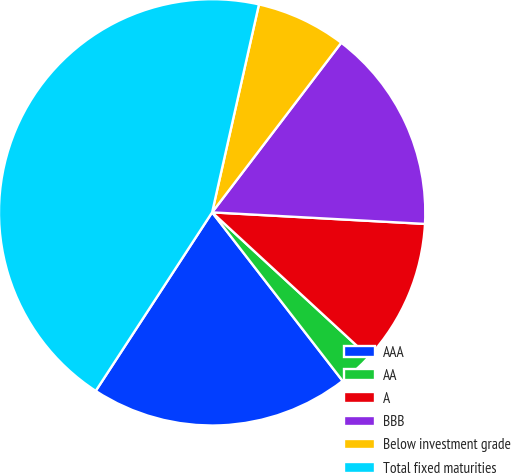Convert chart. <chart><loc_0><loc_0><loc_500><loc_500><pie_chart><fcel>AAA<fcel>AA<fcel>A<fcel>BBB<fcel>Below investment grade<fcel>Total fixed maturities<nl><fcel>19.68%<fcel>2.66%<fcel>10.99%<fcel>15.51%<fcel>6.83%<fcel>44.33%<nl></chart> 